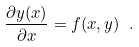<formula> <loc_0><loc_0><loc_500><loc_500>\frac { \partial y ( x ) } { \partial x } = f ( x , y ) \ .</formula> 